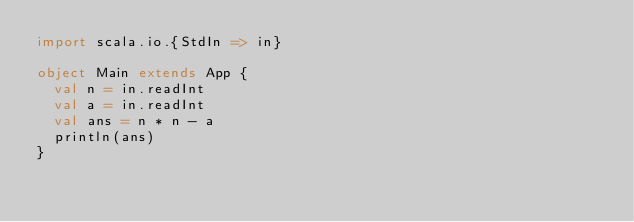<code> <loc_0><loc_0><loc_500><loc_500><_Scala_>import scala.io.{StdIn => in}

object Main extends App {
  val n = in.readInt
  val a = in.readInt
  val ans = n * n - a
  println(ans)
}</code> 